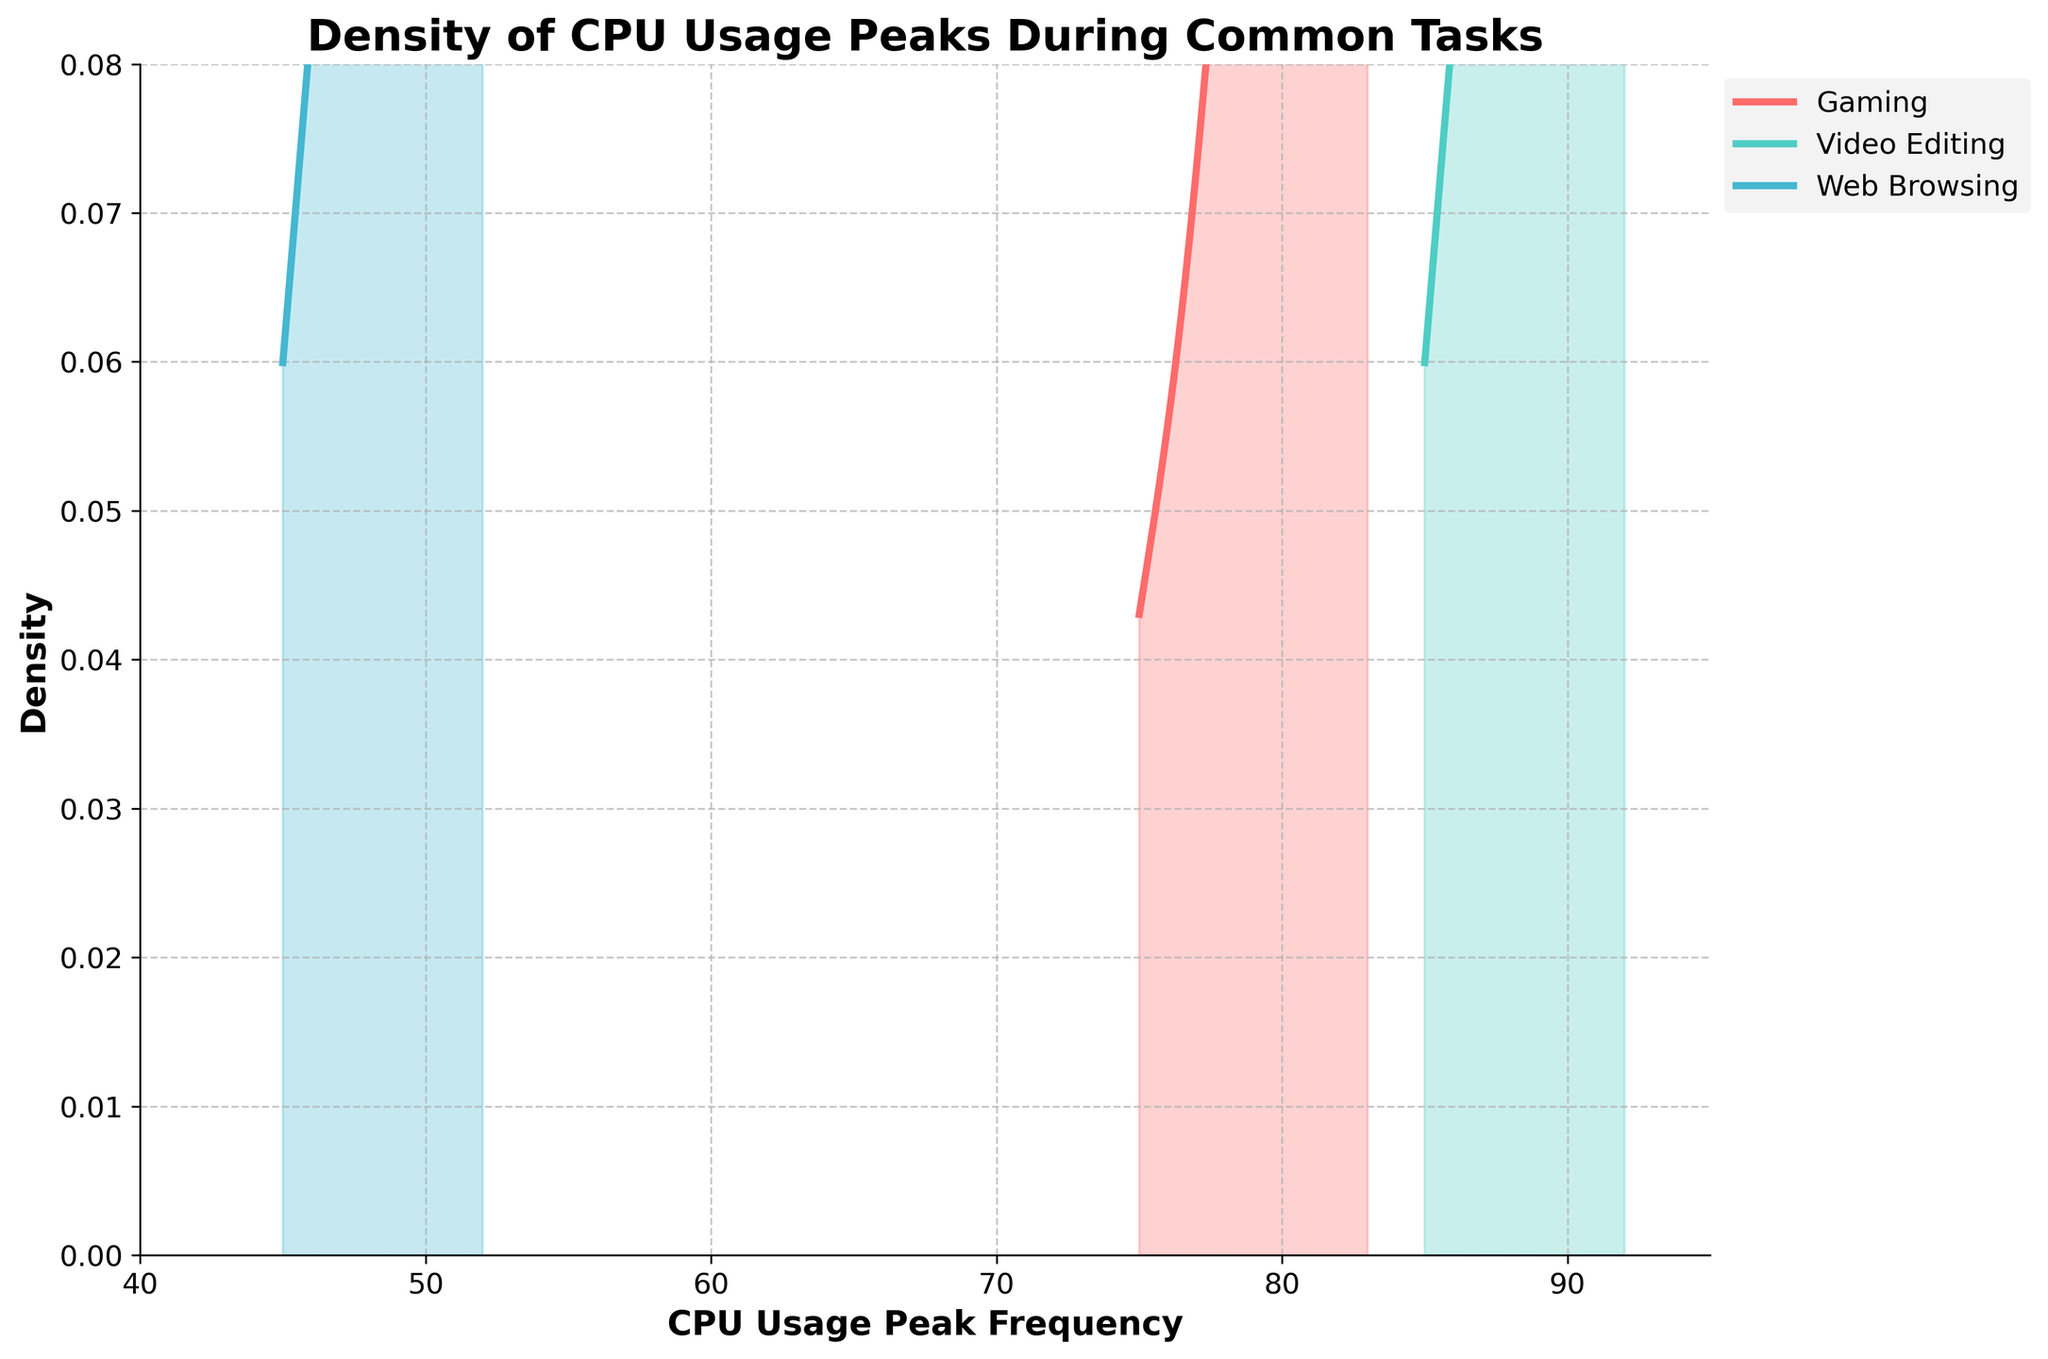What's the title of the figure? The title is at the top of the figure and it summarizes the main topic being shown.
Answer: Density of CPU Usage Peaks During Common Tasks What do the x-axis and y-axis represent? The x-axis represents CPU Usage Peak Frequency, and the y-axis represents Density.
Answer: CPU Usage Peak Frequency and Density Which task shows the highest density peak? By observing the curves, we see that Video Editing has the highest peak density.
Answer: Video Editing What's the general trend of CPU usage peaks in Web Browsing compared to Gaming? The density curve for Web Browsing is shifted towards the left, indicating lower CPU usage peaks compared to Gaming.
Answer: Lower peaks in Web Browsing Between Gaming and Video Editing, which task has a wider spread of CPU usage peaks? The density curve for Gaming is narrower, while Video Editing covers a wider range on the x-axis.
Answer: Video Editing How do the peaks of CPU usage in Web Browsing and Video Editing differ? Web Browsing has a peak around 50, while Video Editing peaks at a higher frequency around 88-92.
Answer: Web Browsing (50), Video Editing (88-92) Which task has the lowest frequency of CPU usage peaks? The density curve for Web Browsing is located at the lowest CPU usage frequencies compared to other tasks.
Answer: Web Browsing What is the approximate maximum density value for Gaming? The peak density value can be observed from the curve's highest point, which is approximately 0.07 for Gaming.
Answer: 0.07 How do the distribution ranges of CPU usage peaks compare between Gaming and Web Browsing? Gaming peaks are consistently higher (75-83) compared to Web Browsing (45-52), indicating a higher CPU demand during gaming.
Answer: Higher for Gaming Is the CPU usage peak frequency in Video Editing more variable than in Web Browsing? Video Editing shows peaks across a broader range (85-92) compared to Web Browsing (45-52), indicating more variability.
Answer: Yes 